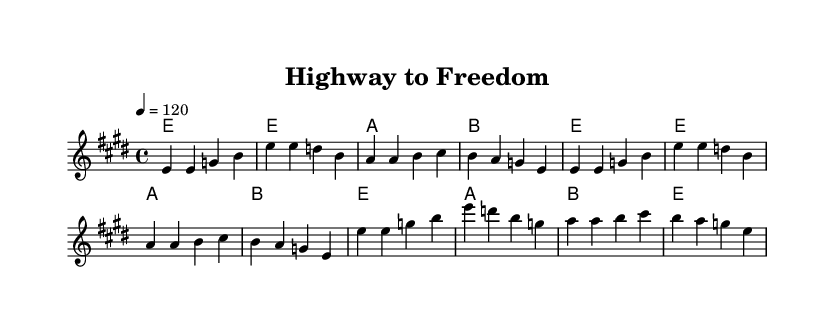What is the key signature of this music? The key signature is E major, which has four sharps (F#, C#, G#, D#).
Answer: E major What is the time signature of this music? The time signature shown in the music is 4/4, which means there are four beats in a measure and a quarter note gets one beat.
Answer: 4/4 What is the tempo marking for this piece? The tempo marking indicates a speed of 120 beats per minute, which is relatively moderate and suits a rock anthem's driving feel.
Answer: 120 How many measures are in the chorus section? By counting the measures in the chorus section, we note that there are four measures, which is standard for a chorus in popular music.
Answer: 4 What is the primary thematic focus of the lyrics? The lyrics focus on themes of freedom and life on the open road, as suggested by phrases like "highway to freedom" and references to "the open road."
Answer: Freedom How does the chord progression in the verse compare to the chord progression in the chorus? Both sections use similar chord progressions with E and A chords, but the chorus adds a B chord at the end, providing a slight variation that enhances its climax.
Answer: Similar What emotion do you think the title "Highway to Freedom" conveys about the music's theme? The title suggests a feeling of liberation and adventure, aligning with the classic rock sentiment of enjoying life as you travel without constraints.
Answer: Liberation 